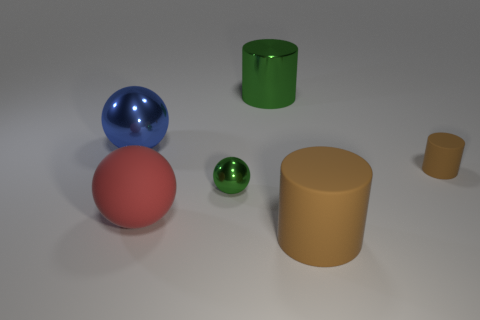Does the arrangement of the objects in the image suggest anything about their purpose or context? The arrangement of the objects does not explicitly suggest a particular purpose or real-life context, as they appear to be randomly placed. This type of setting is typical for a 3D modeling or rendering test where the focus is on the display of shapes, colors, and materials rather than depicting a scene from real life. 